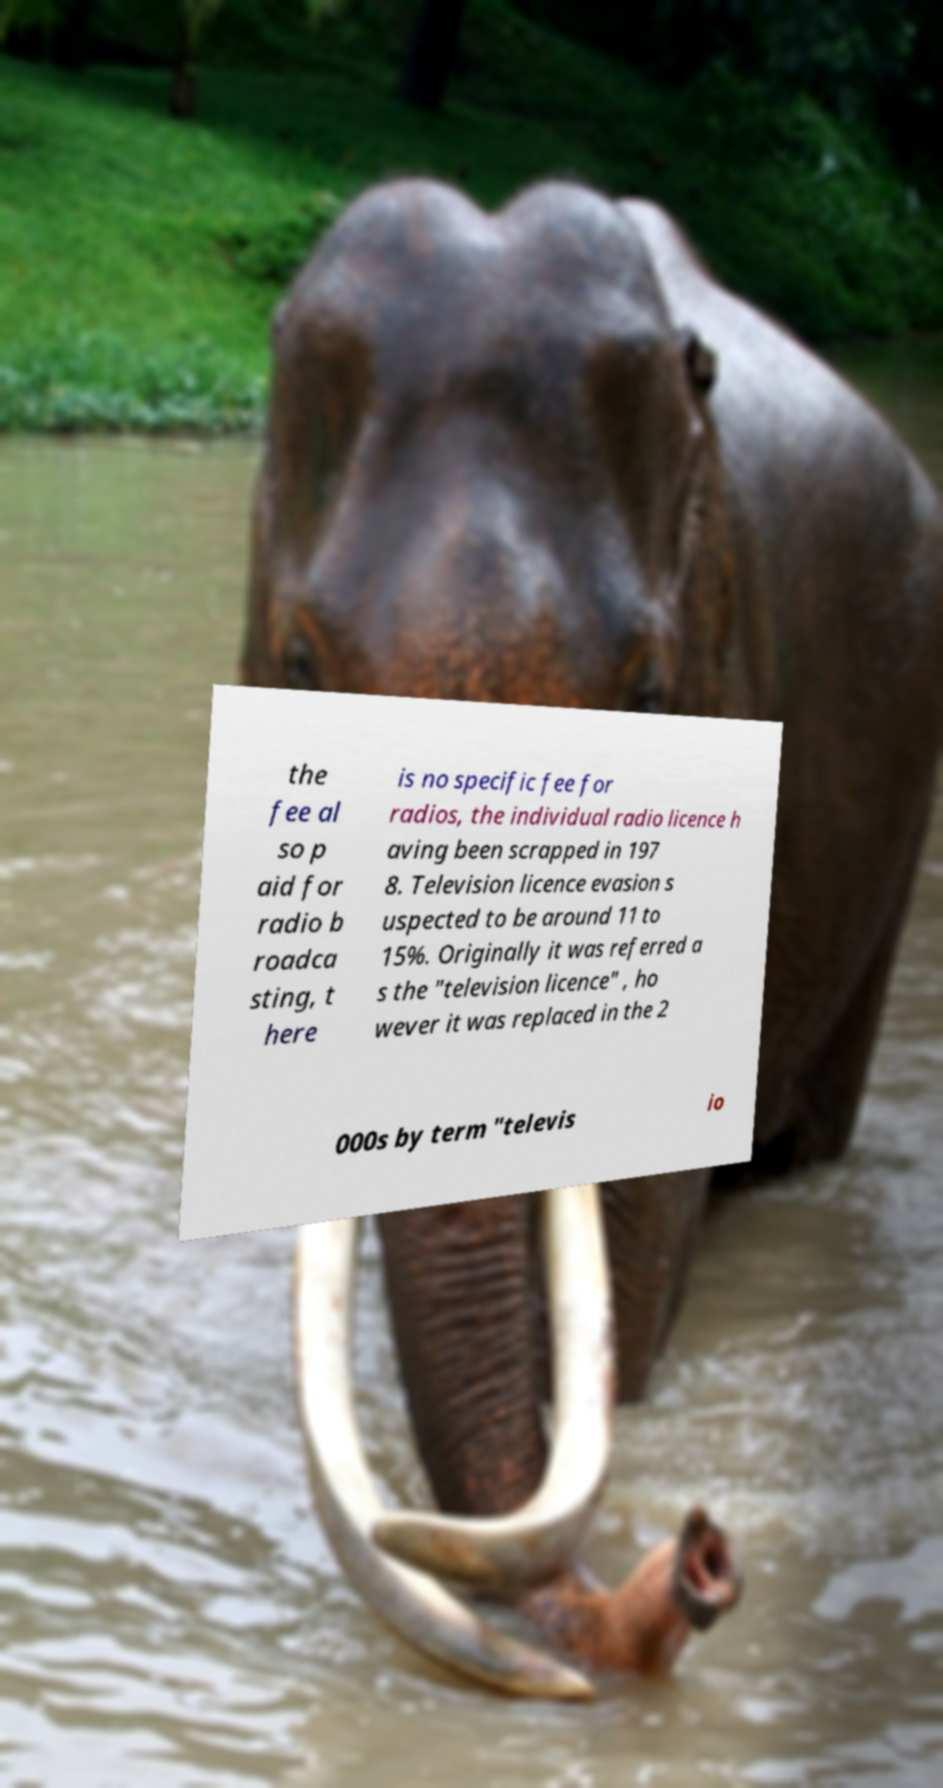Could you extract and type out the text from this image? the fee al so p aid for radio b roadca sting, t here is no specific fee for radios, the individual radio licence h aving been scrapped in 197 8. Television licence evasion s uspected to be around 11 to 15%. Originally it was referred a s the "television licence" , ho wever it was replaced in the 2 000s by term "televis io 